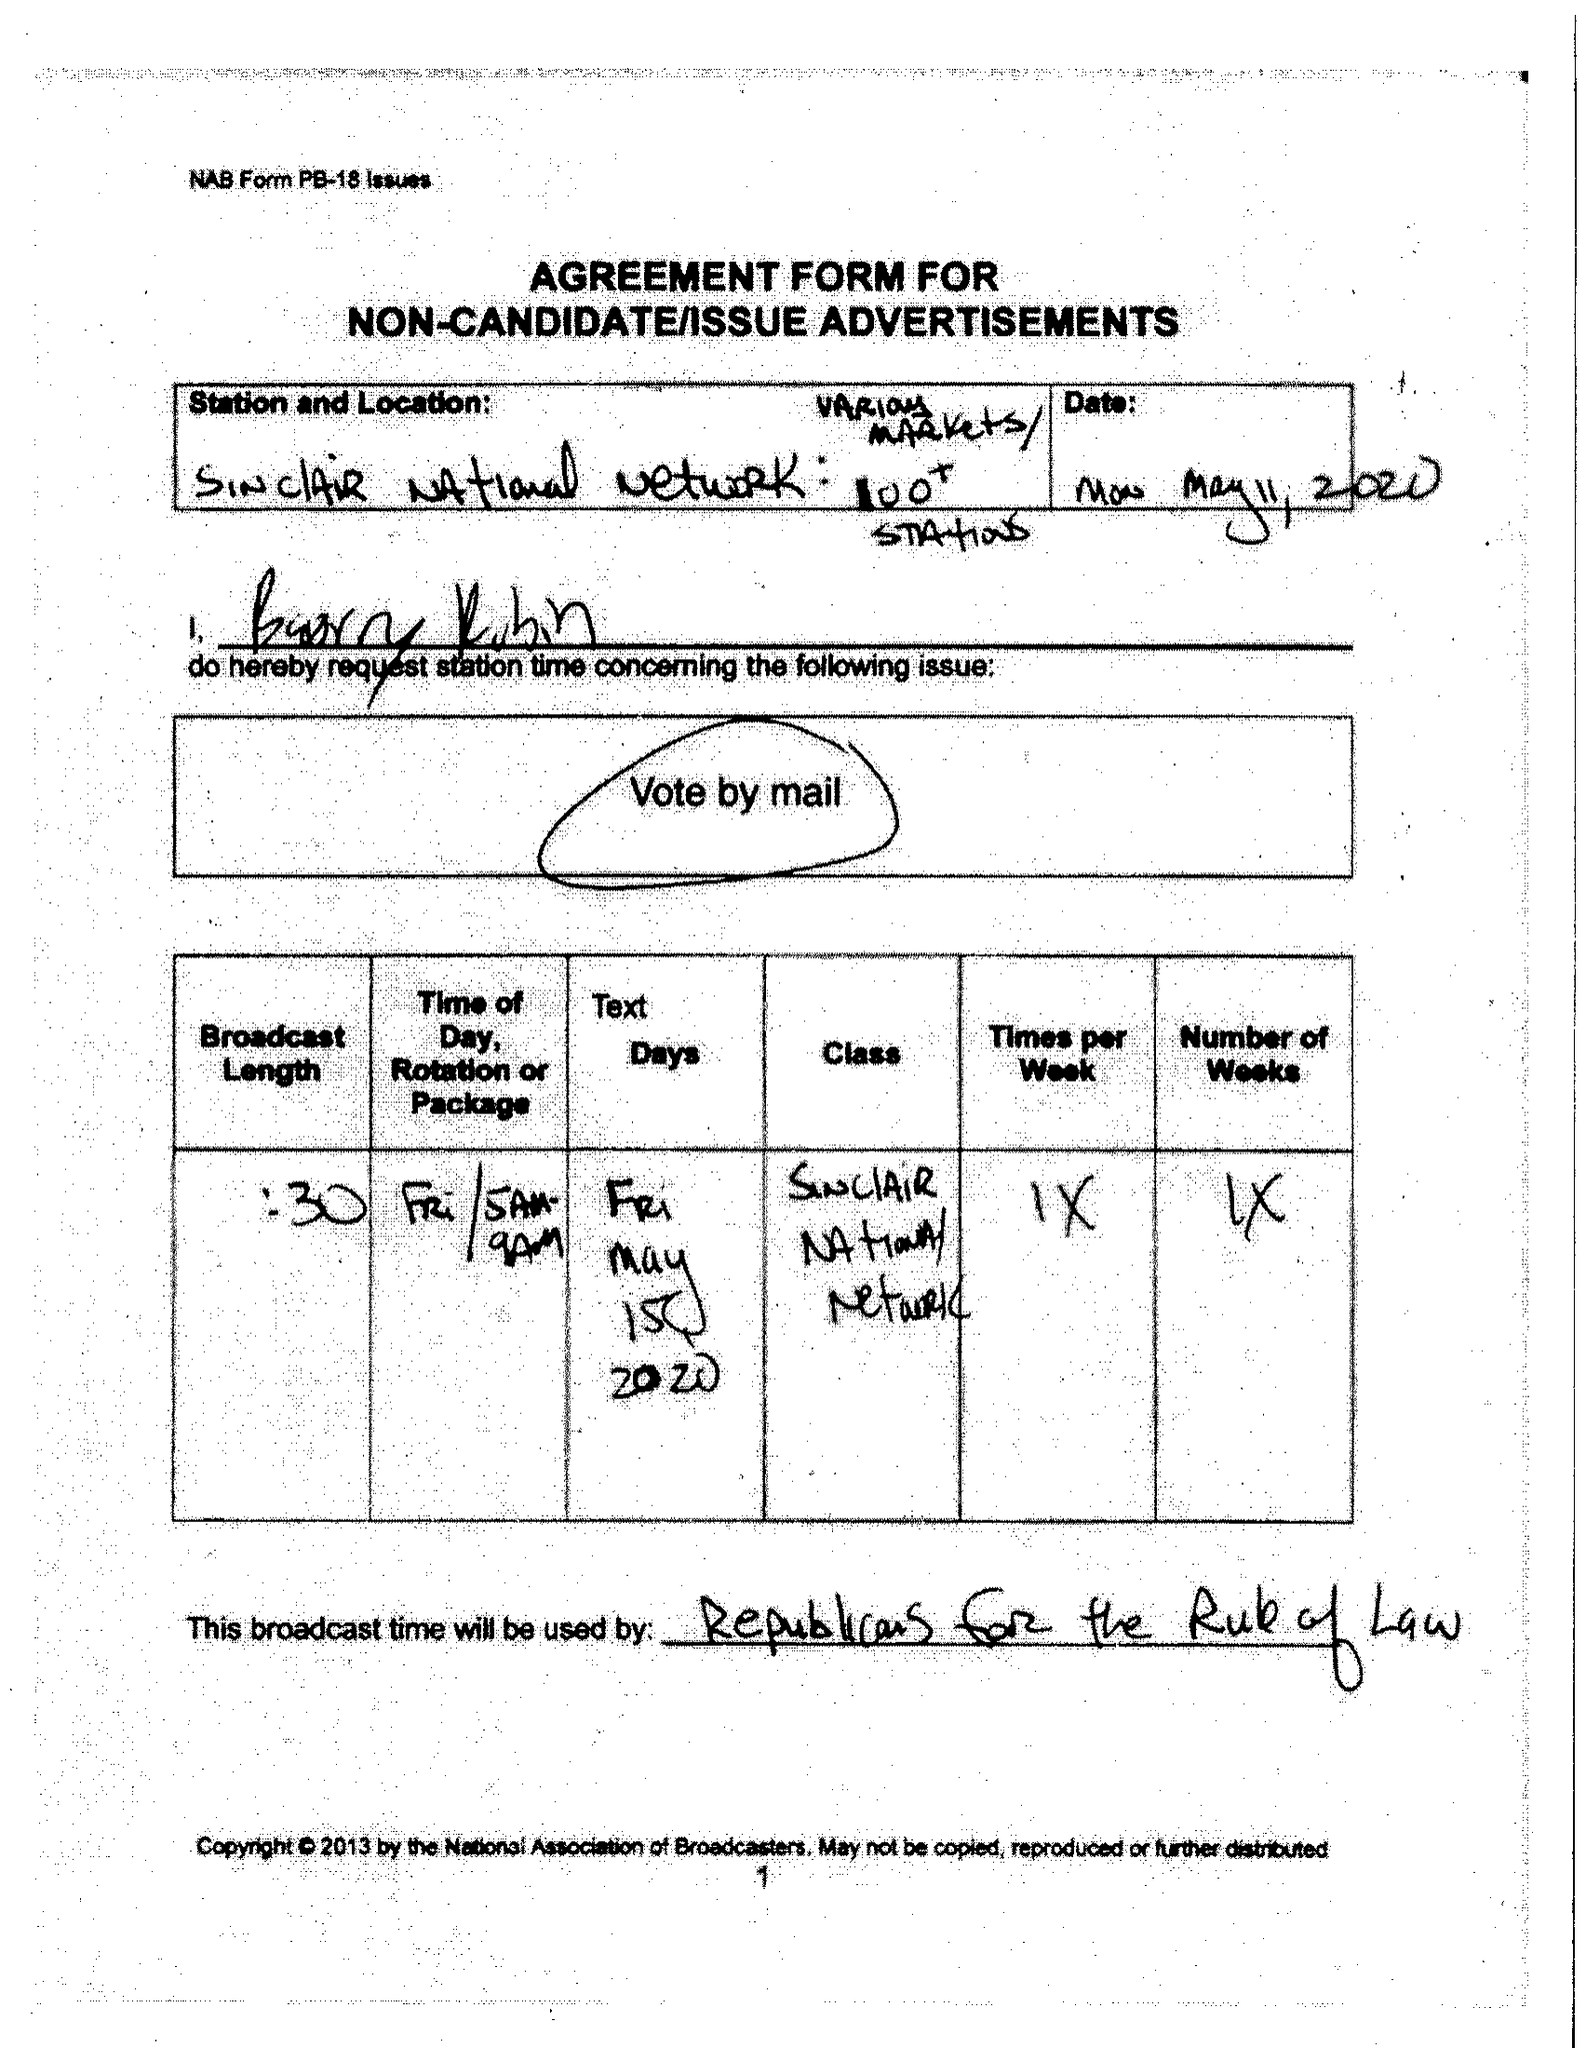What is the value for the contract_num?
Answer the question using a single word or phrase. None 